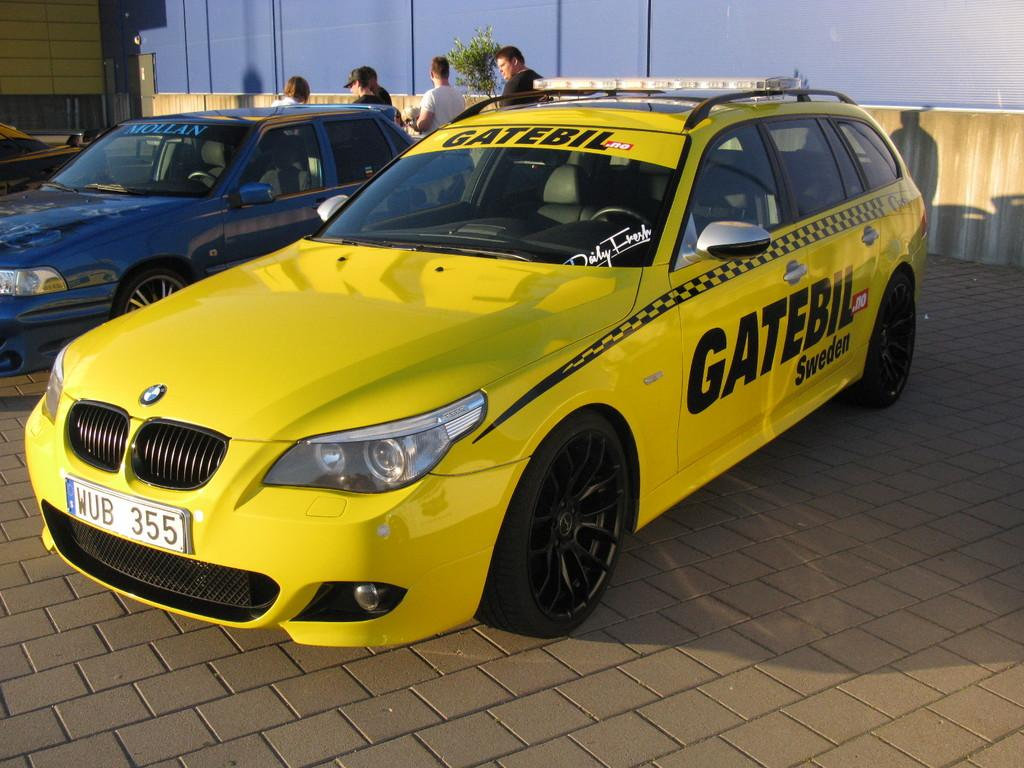<image>
Create a compact narrative representing the image presented. A yellow car that says Gatebil Sweden on it. 